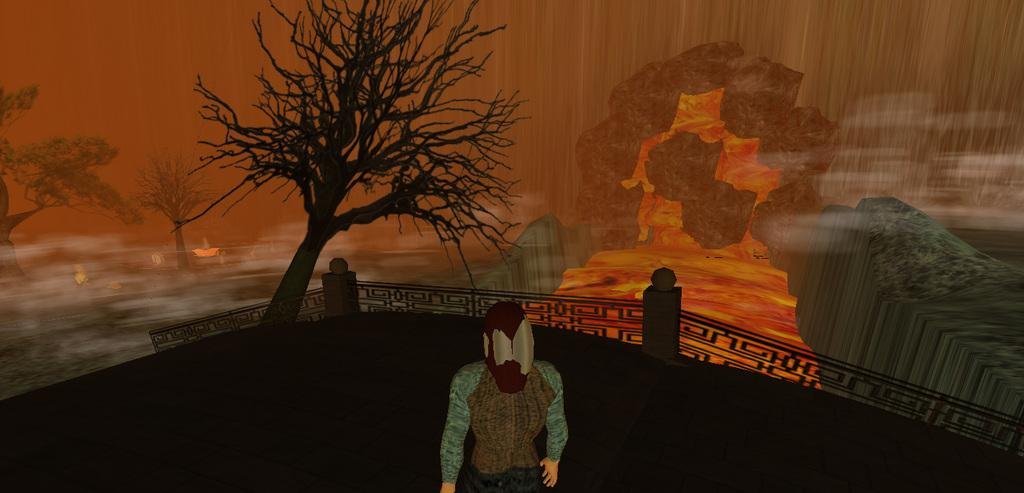What type of image is being described? The image is an animation. Can you describe the main subject in the image? There is a person in the middle of the image. What is located behind the person in the image? There is a tree behind the person. Where is the nest located in the image? There is no nest present in the image. What type of footwear is the person wearing in the image? The provided facts do not mention any footwear, so it cannot be determined from the image. 